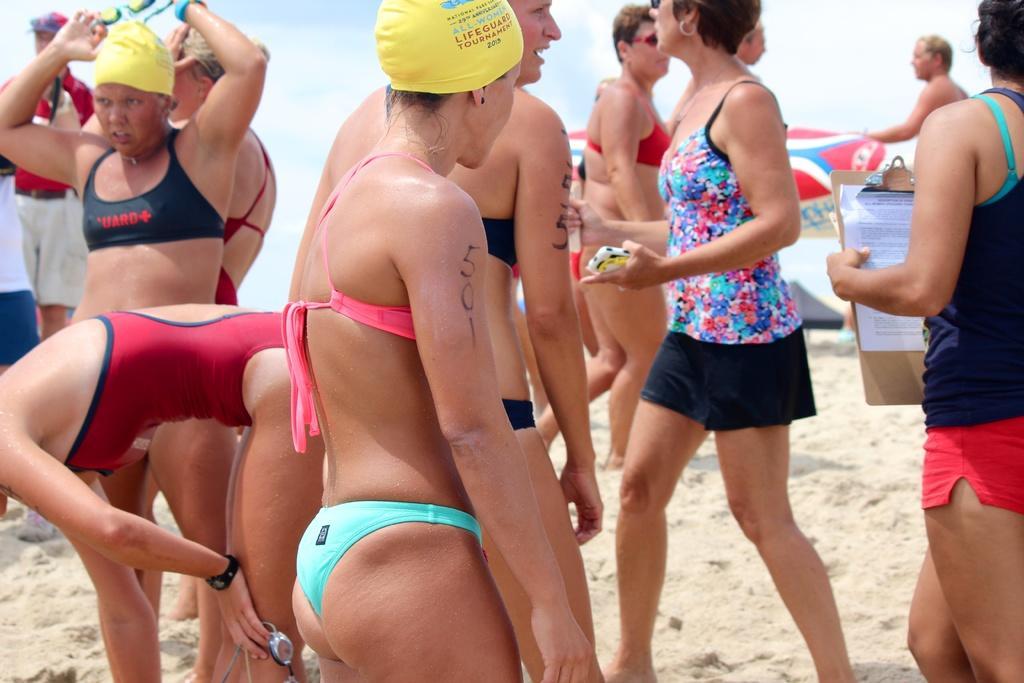In one or two sentences, can you explain what this image depicts? In this image we can see many people and few people are holding some objects in their hands. There is a beach in the image. 